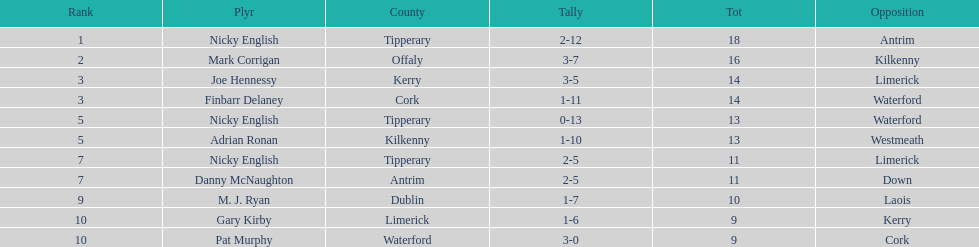How many times was waterford the opposition? 2. 